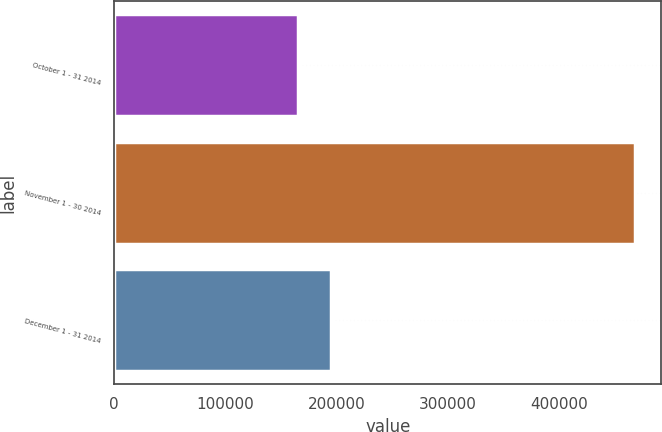<chart> <loc_0><loc_0><loc_500><loc_500><bar_chart><fcel>October 1 - 31 2014<fcel>November 1 - 30 2014<fcel>December 1 - 31 2014<nl><fcel>164800<fcel>468128<fcel>195133<nl></chart> 